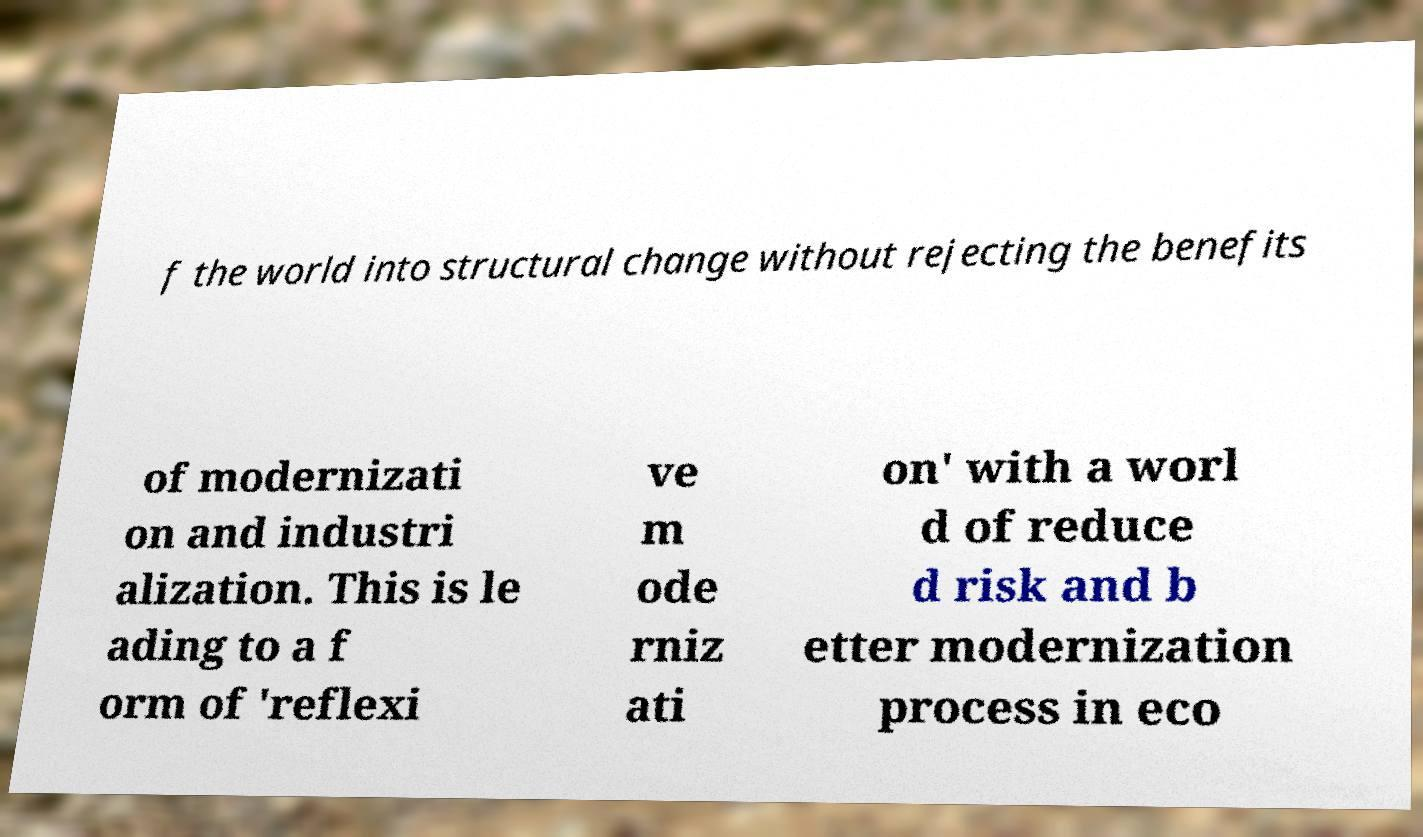Can you accurately transcribe the text from the provided image for me? f the world into structural change without rejecting the benefits of modernizati on and industri alization. This is le ading to a f orm of 'reflexi ve m ode rniz ati on' with a worl d of reduce d risk and b etter modernization process in eco 